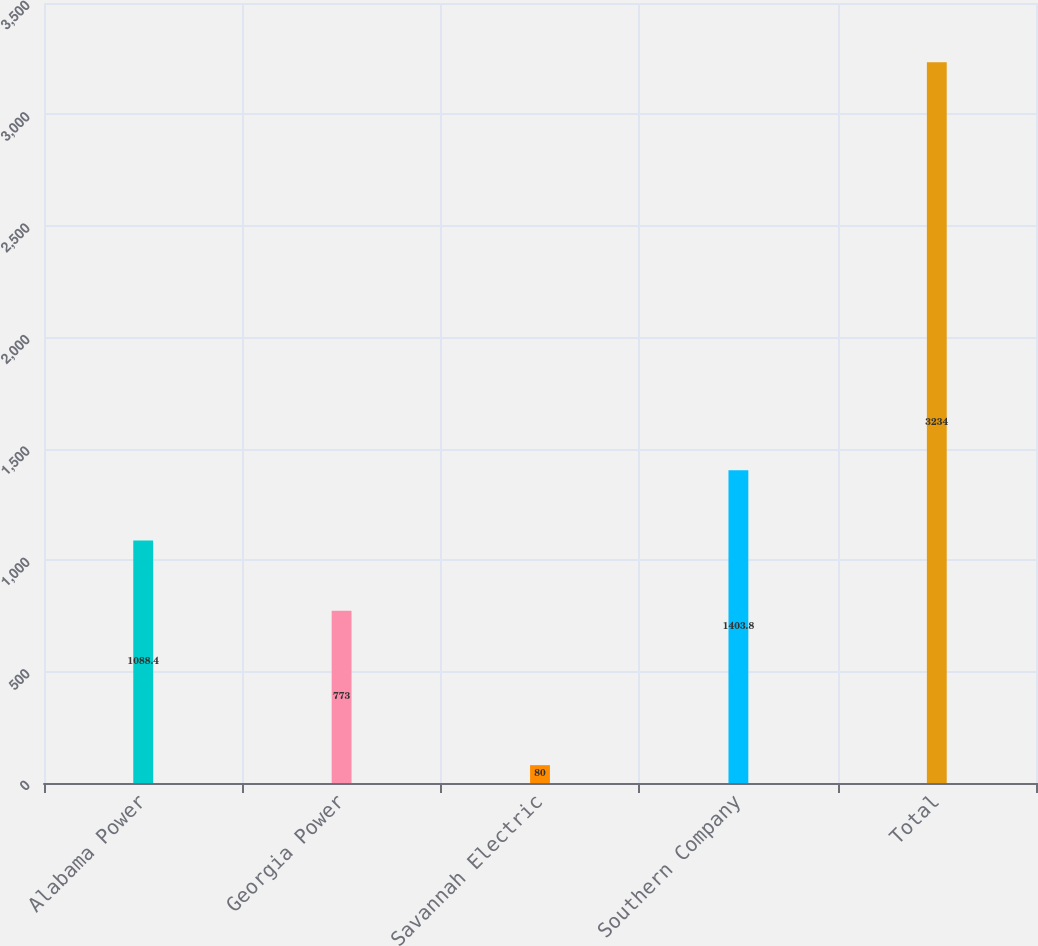Convert chart to OTSL. <chart><loc_0><loc_0><loc_500><loc_500><bar_chart><fcel>Alabama Power<fcel>Georgia Power<fcel>Savannah Electric<fcel>Southern Company<fcel>Total<nl><fcel>1088.4<fcel>773<fcel>80<fcel>1403.8<fcel>3234<nl></chart> 